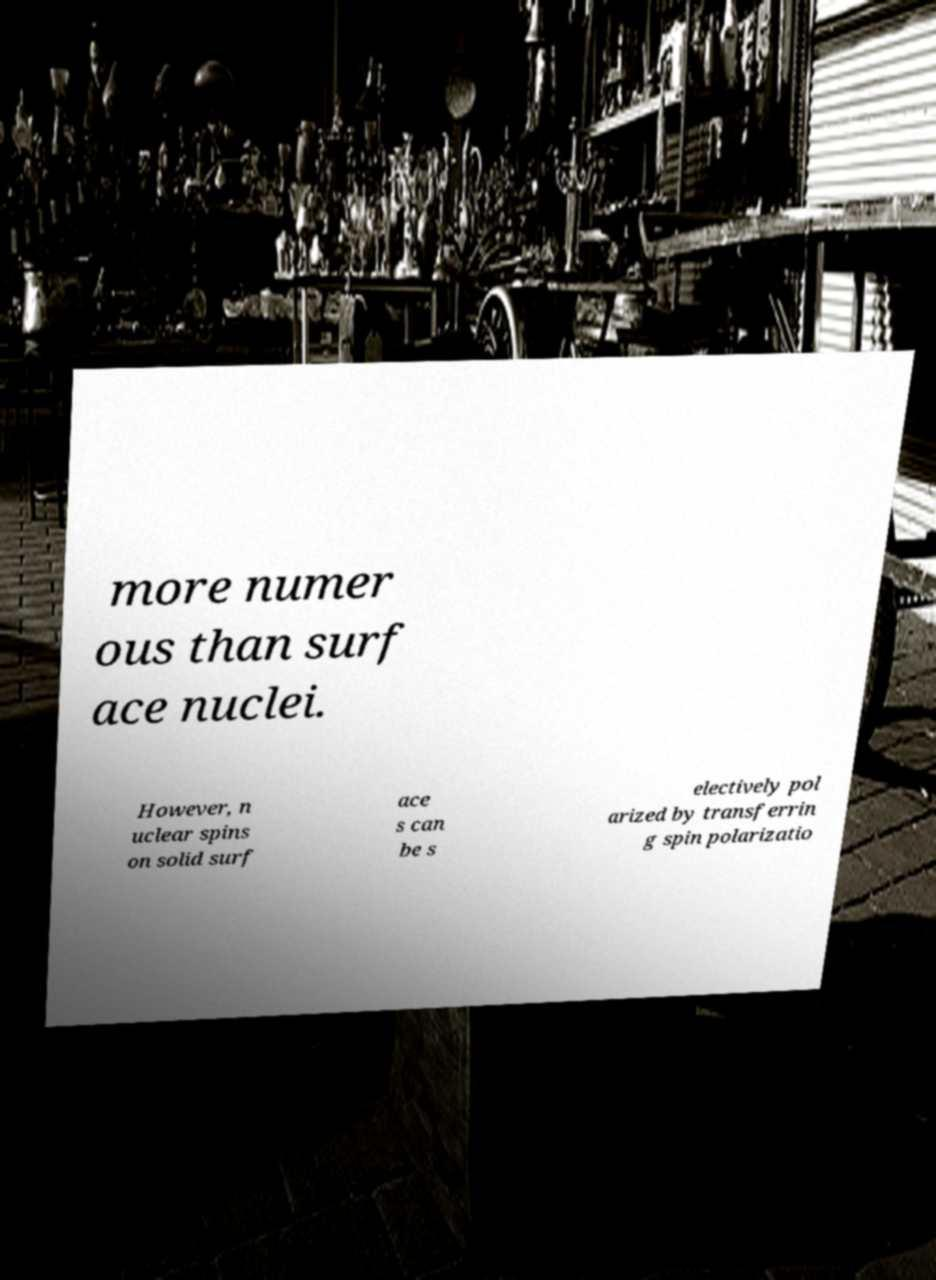Can you accurately transcribe the text from the provided image for me? more numer ous than surf ace nuclei. However, n uclear spins on solid surf ace s can be s electively pol arized by transferrin g spin polarizatio 